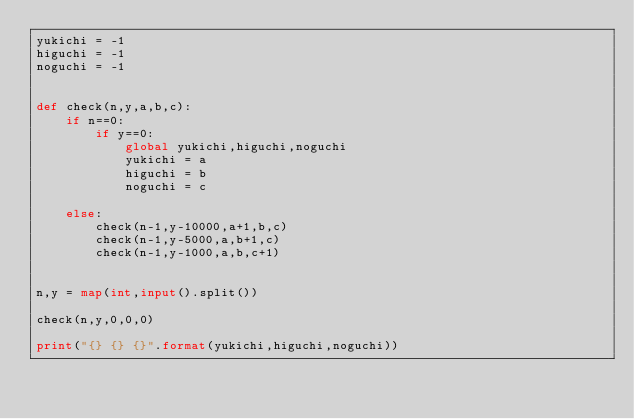Convert code to text. <code><loc_0><loc_0><loc_500><loc_500><_Python_>yukichi = -1
higuchi = -1
noguchi = -1


def check(n,y,a,b,c):
    if n==0:
        if y==0:
            global yukichi,higuchi,noguchi
            yukichi = a
            higuchi = b
            noguchi = c
            
    else:
        check(n-1,y-10000,a+1,b,c)
        check(n-1,y-5000,a,b+1,c)
        check(n-1,y-1000,a,b,c+1)


n,y = map(int,input().split())

check(n,y,0,0,0)

print("{} {} {}".format(yukichi,higuchi,noguchi))
</code> 